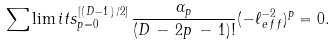<formula> <loc_0><loc_0><loc_500><loc_500>\sum \lim i t s _ { p = 0 } ^ { [ ( \, D - 1 \, ) \, / 2 ] } \, \frac { \alpha _ { p } } { ( D \, - \, 2 p \, - \, 1 ) ! } ( - \ell _ { \, e \, f \, f } ^ { - 2 } ) ^ { p } = 0 .</formula> 